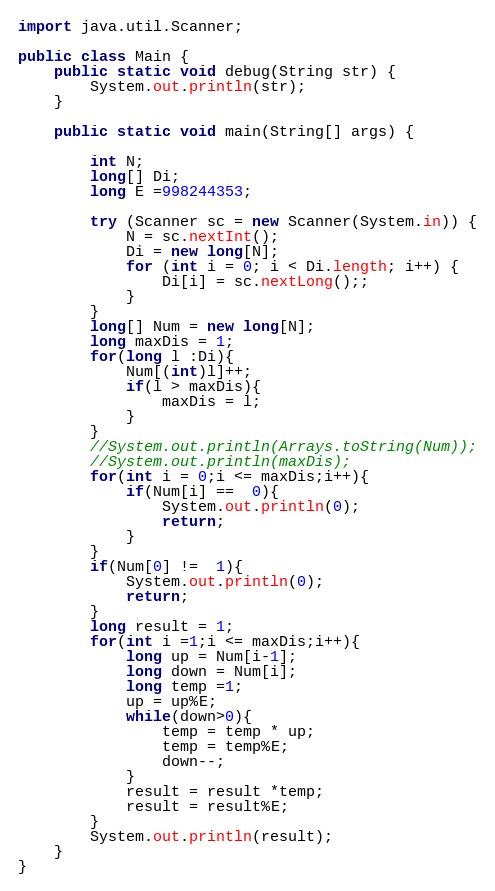Convert code to text. <code><loc_0><loc_0><loc_500><loc_500><_Java_>
import java.util.Scanner;

public class Main {
    public static void debug(String str) {
        System.out.println(str);
    }

    public static void main(String[] args) {

        int N;
        long[] Di;
        long E =998244353;

        try (Scanner sc = new Scanner(System.in)) {
            N = sc.nextInt();
            Di = new long[N];
            for (int i = 0; i < Di.length; i++) {
                Di[i] = sc.nextLong();;
            }
        }
        long[] Num = new long[N];
        long maxDis = 1;
        for(long l :Di){
            Num[(int)l]++;
            if(l > maxDis){
                maxDis = l;
            }
        }
        //System.out.println(Arrays.toString(Num));
        //System.out.println(maxDis);
        for(int i = 0;i <= maxDis;i++){
            if(Num[i] ==  0){
                System.out.println(0);
                return;
            }
        }
        if(Num[0] !=  1){
            System.out.println(0);
            return;
        }
        long result = 1;
        for(int i =1;i <= maxDis;i++){
            long up = Num[i-1];
            long down = Num[i];
            long temp =1;
            up = up%E;
            while(down>0){
                temp = temp * up;
                temp = temp%E;
                down--;
            }
            result = result *temp;
            result = result%E;
        }
        System.out.println(result);
    }
}
</code> 